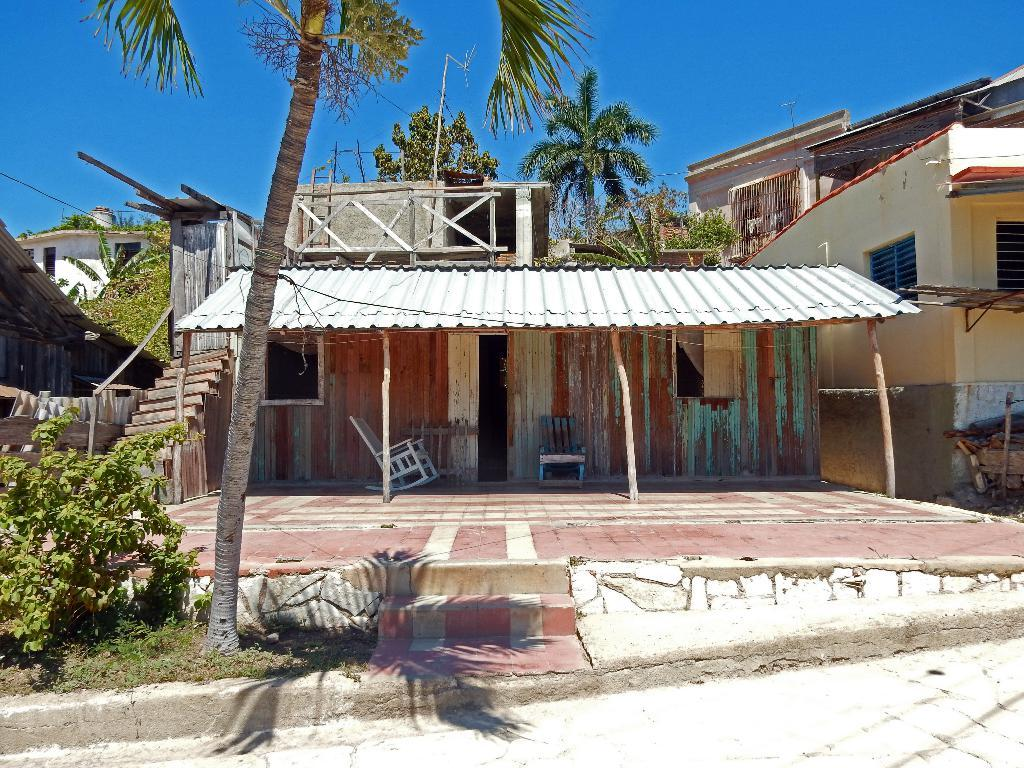What type of view is shown in the image? The image is an outside view. What structures can be seen in the image? There are houses in the image. What type of vegetation is present in the image? There are trees and plants in the image. What is at the bottom of the image? There is a road at the bottom of the image. What is visible at the top of the image? The sky is visible at the top of the image. What color is the sweater worn by the tree in the image? There is no sweater present on the trees in the image, as trees are not capable of wearing clothing. 